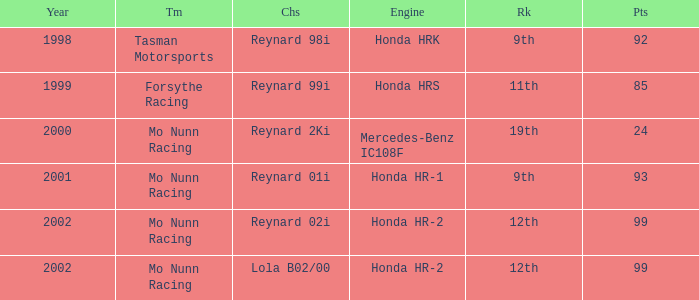What is the total number of points of the honda hr-1 engine? 1.0. 